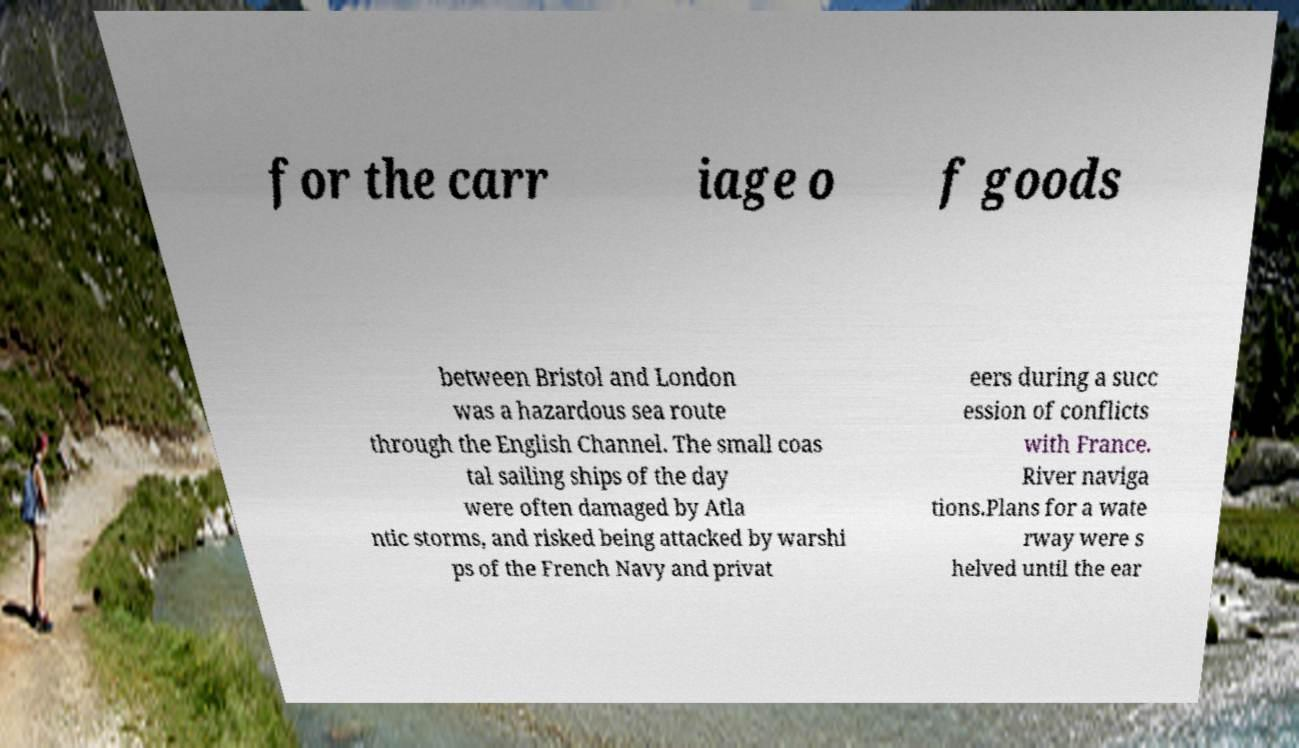Can you read and provide the text displayed in the image?This photo seems to have some interesting text. Can you extract and type it out for me? for the carr iage o f goods between Bristol and London was a hazardous sea route through the English Channel. The small coas tal sailing ships of the day were often damaged by Atla ntic storms, and risked being attacked by warshi ps of the French Navy and privat eers during a succ ession of conflicts with France. River naviga tions.Plans for a wate rway were s helved until the ear 